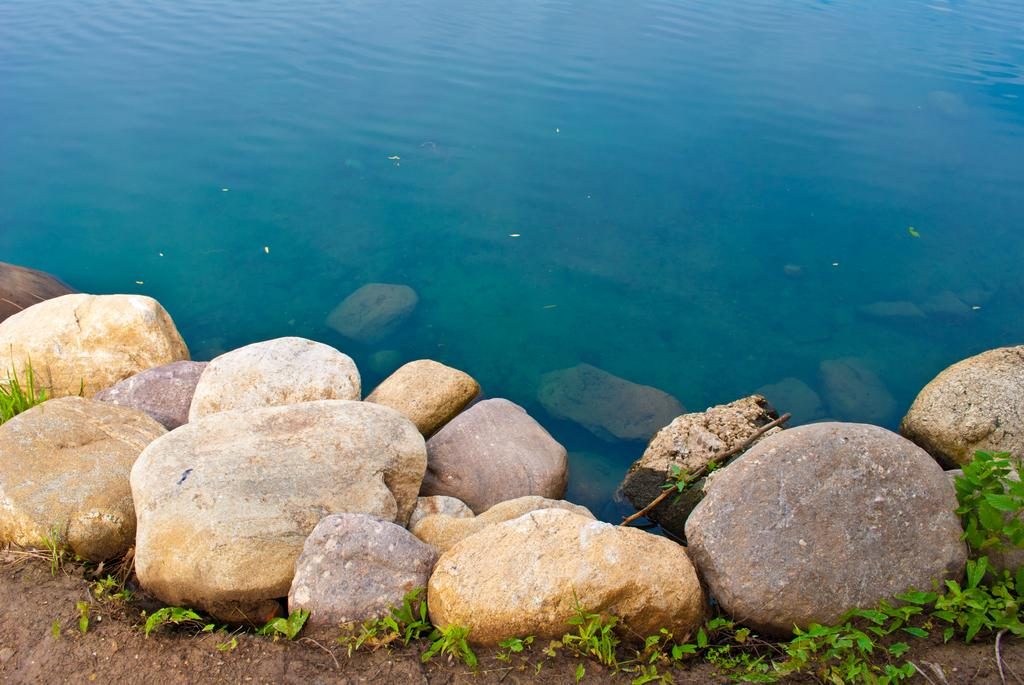What can be seen in the background of the image? There is water visible in the background of the image. What is located at the bottom of the image? There are rocks and plants at the bottom of the image. What type of surface is visible at the bottom of the image? The ground is visible at the bottom of the image. What is the title of the book that is being read by the wren in the image? There is no wren or book present in the image. 